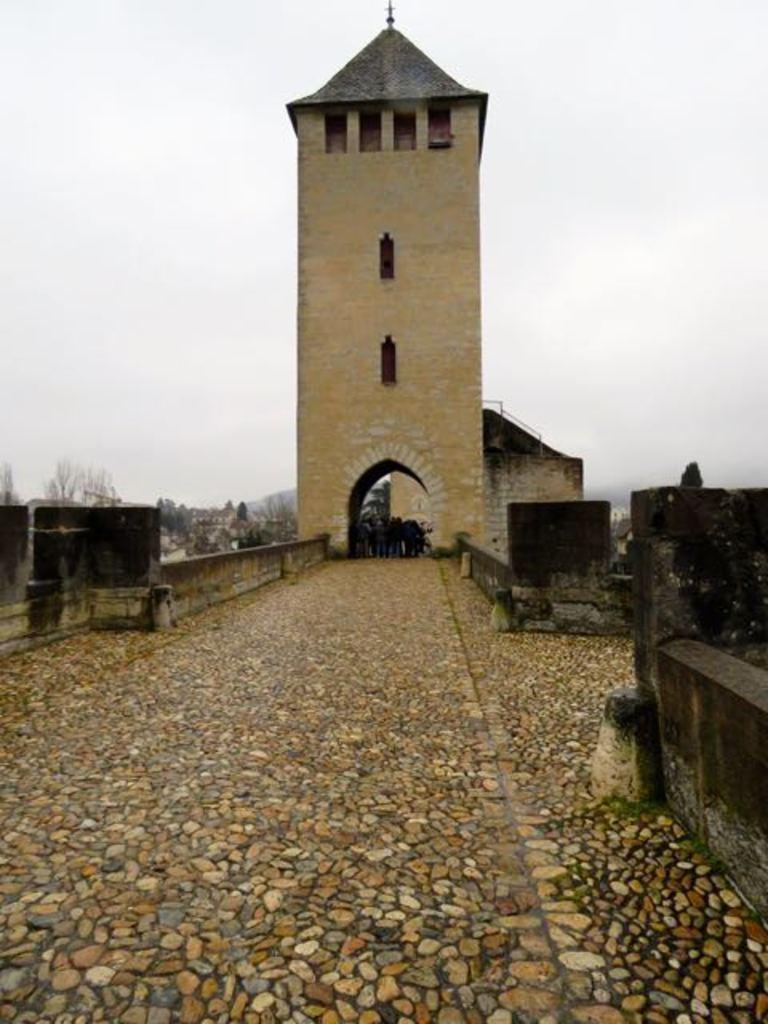Describe this image in one or two sentences. In this image I can see a building tower, a wall and some other objects. In the background I can see trees and the sky. 